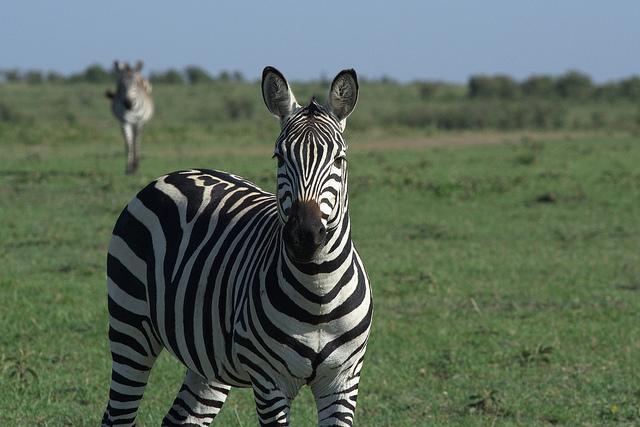How many animals are in the background?
Quick response, please. 1. What are the animals standing on?
Concise answer only. Grass. Is there a trail here?
Quick response, please. Yes. 